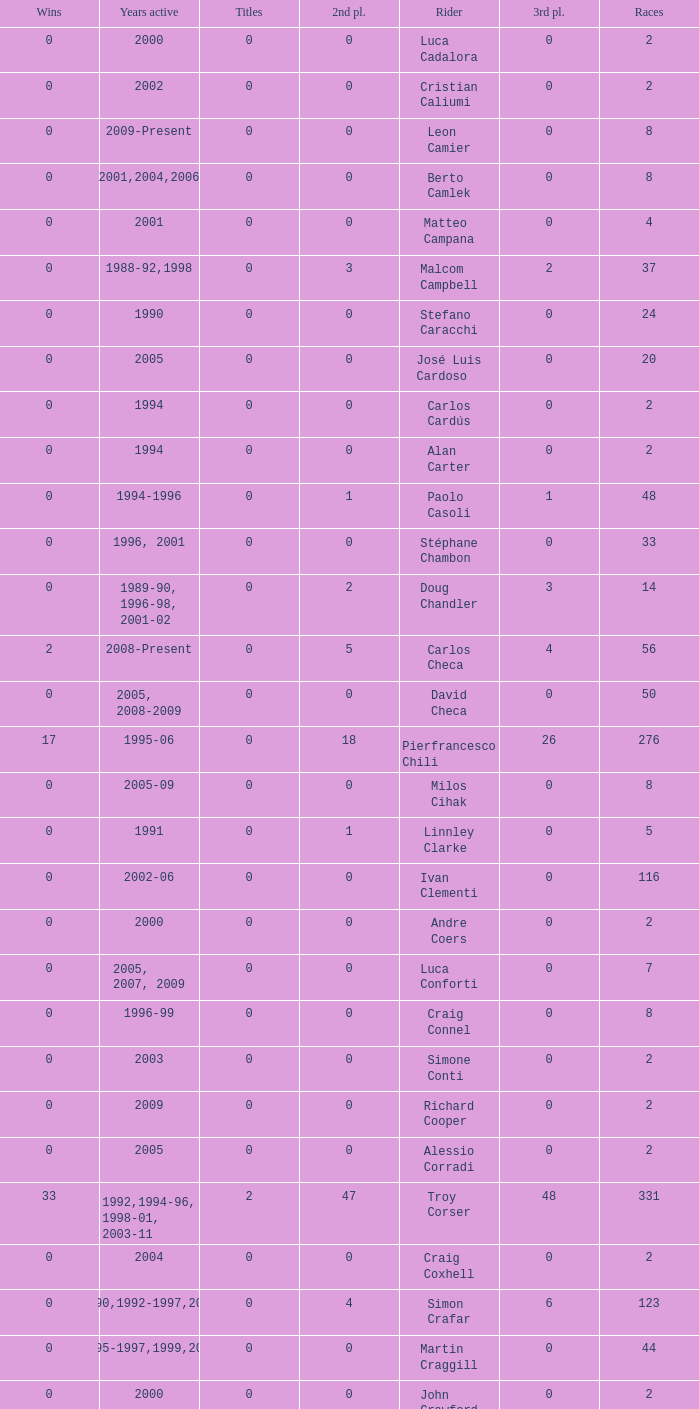What is the total number of wins for riders with fewer than 56 races and more than 0 titles? 0.0. Parse the table in full. {'header': ['Wins', 'Years active', 'Titles', '2nd pl.', 'Rider', '3rd pl.', 'Races'], 'rows': [['0', '2000', '0', '0', 'Luca Cadalora', '0', '2'], ['0', '2002', '0', '0', 'Cristian Caliumi', '0', '2'], ['0', '2009-Present', '0', '0', 'Leon Camier', '0', '8'], ['0', '2001,2004,2006', '0', '0', 'Berto Camlek', '0', '8'], ['0', '2001', '0', '0', 'Matteo Campana', '0', '4'], ['0', '1988-92,1998', '0', '3', 'Malcom Campbell', '2', '37'], ['0', '1990', '0', '0', 'Stefano Caracchi', '0', '24'], ['0', '2005', '0', '0', 'José Luis Cardoso', '0', '20'], ['0', '1994', '0', '0', 'Carlos Cardús', '0', '2'], ['0', '1994', '0', '0', 'Alan Carter', '0', '2'], ['0', '1994-1996', '0', '1', 'Paolo Casoli', '1', '48'], ['0', '1996, 2001', '0', '0', 'Stéphane Chambon', '0', '33'], ['0', '1989-90, 1996-98, 2001-02', '0', '2', 'Doug Chandler', '3', '14'], ['2', '2008-Present', '0', '5', 'Carlos Checa', '4', '56'], ['0', '2005, 2008-2009', '0', '0', 'David Checa', '0', '50'], ['17', '1995-06', '0', '18', 'Pierfrancesco Chili', '26', '276'], ['0', '2005-09', '0', '0', 'Milos Cihak', '0', '8'], ['0', '1991', '0', '1', 'Linnley Clarke', '0', '5'], ['0', '2002-06', '0', '0', 'Ivan Clementi', '0', '116'], ['0', '2000', '0', '0', 'Andre Coers', '0', '2'], ['0', '2005, 2007, 2009', '0', '0', 'Luca Conforti', '0', '7'], ['0', '1996-99', '0', '0', 'Craig Connel', '0', '8'], ['0', '2003', '0', '0', 'Simone Conti', '0', '2'], ['0', '2009', '0', '0', 'Richard Cooper', '0', '2'], ['0', '2005', '0', '0', 'Alessio Corradi', '0', '2'], ['33', '1992,1994-96, 1998-01, 2003-11', '2', '47', 'Troy Corser', '48', '331'], ['0', '2004', '0', '0', 'Craig Coxhell', '0', '2'], ['0', '1990,1992-1997,2000', '0', '4', 'Simon Crafar', '6', '123'], ['0', '1995-1997,1999,2001', '0', '0', 'Martin Craggill', '0', '44'], ['0', '2000', '0', '0', 'John Crawford', '0', '2'], ['0', '1989,1991,1997', '0', '0', 'Steve Crevier', '1', '11'], ['0', '2004-05, 2007', '0', '0', 'Stefano Cruciani', '0', '8'], ['0', '2003', '0', '0', 'Steven Cutting', '0', '2']]} 